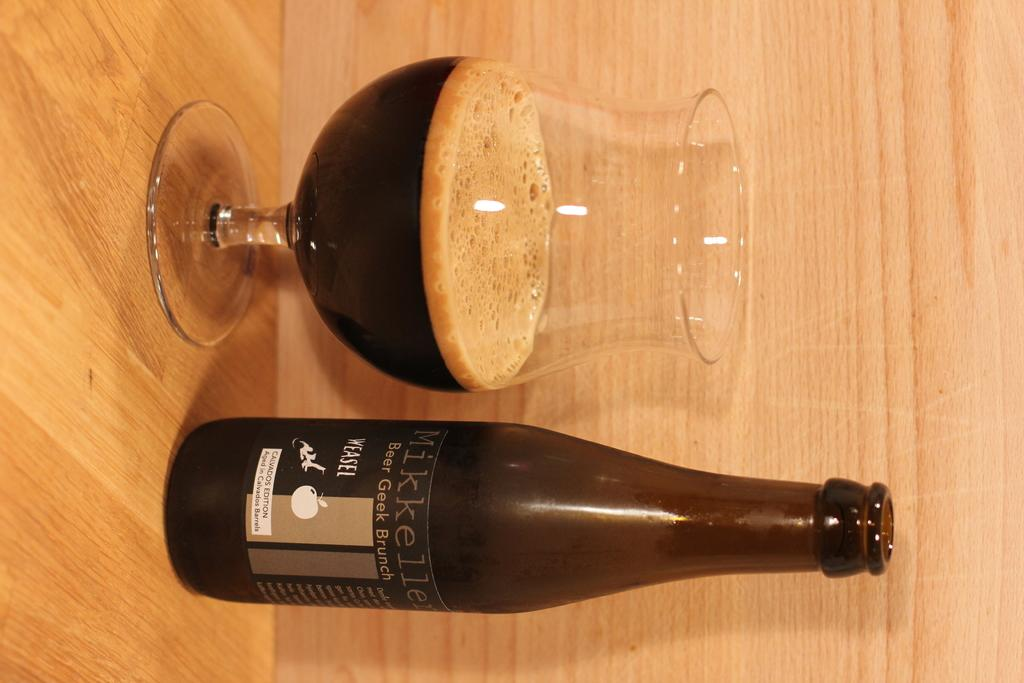<image>
Create a compact narrative representing the image presented. a glass and bottle of Beer Geek Brunch on a table 